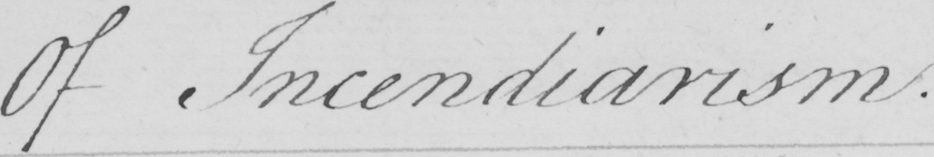What text is written in this handwritten line? Of Indendiarism 